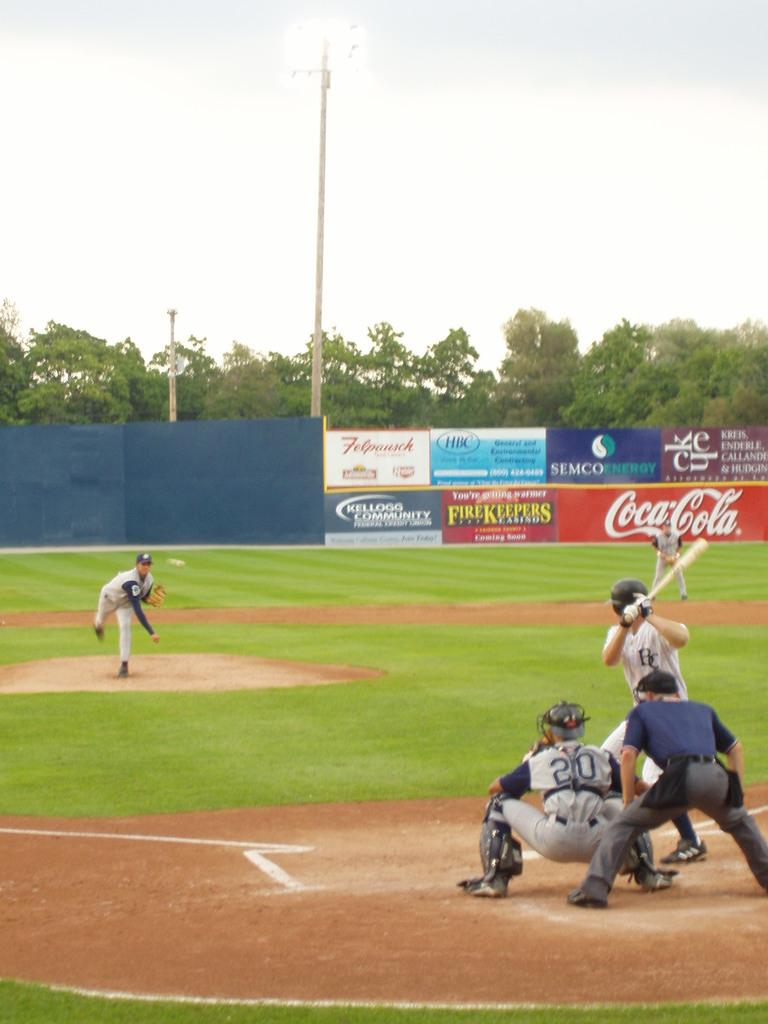<image>
Give a short and clear explanation of the subsequent image. A Coca-Cola sponred baseball game is in progress and the batter is about to swing for the ball. 